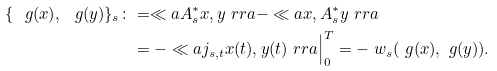Convert formula to latex. <formula><loc_0><loc_0><loc_500><loc_500>\{ \ g ( x ) , \ g ( y ) \} _ { s } \colon & = \ll a A _ { s } ^ { * } x , y \ r r a - \ll a x , A _ { s } ^ { * } y \ r r a \\ & = - \ll a j _ { s , t } x ( t ) , y ( t ) \ r r a \Big | _ { 0 } ^ { T } = - \ w _ { s } ( \ g ( x ) , \ g ( y ) ) .</formula> 